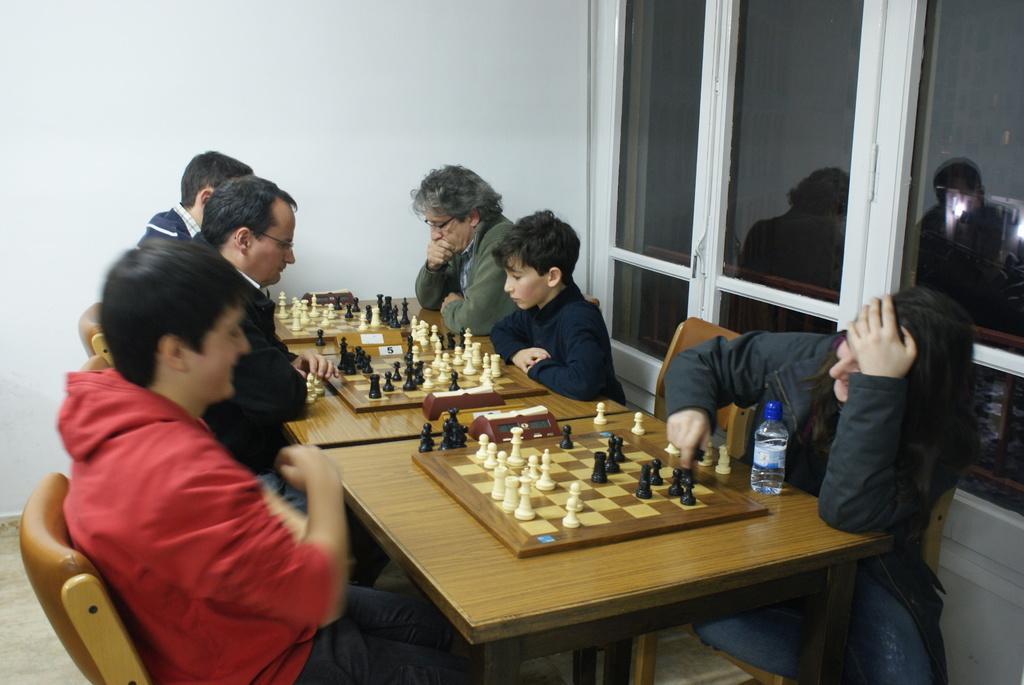Please provide a concise description of this image. 6 people are playing the chess by sitting on the chairs. 